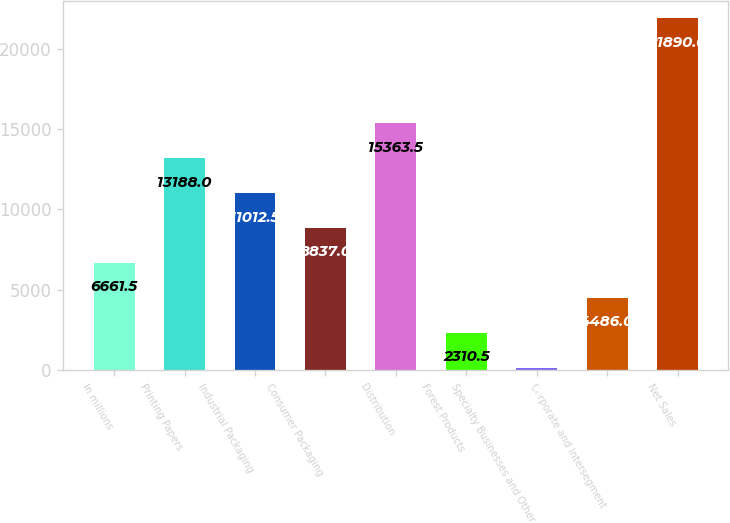<chart> <loc_0><loc_0><loc_500><loc_500><bar_chart><fcel>In millions<fcel>Printing Papers<fcel>Industrial Packaging<fcel>Consumer Packaging<fcel>Distribution<fcel>Forest Products<fcel>Specialty Businesses and Other<fcel>Corporate and Intersegment<fcel>Net Sales<nl><fcel>6661.5<fcel>13188<fcel>11012.5<fcel>8837<fcel>15363.5<fcel>2310.5<fcel>135<fcel>4486<fcel>21890<nl></chart> 